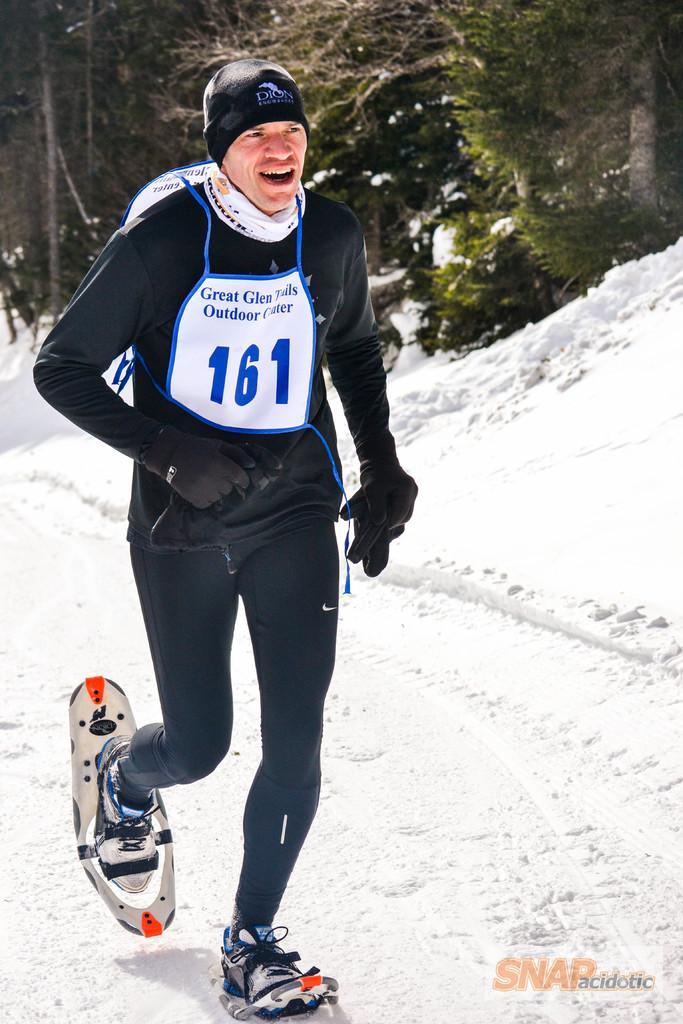How would you summarize this image in a sentence or two? In this image in front there is a person running on the snow. In the background of the image there are trees. There is some text on the right side of the image. 